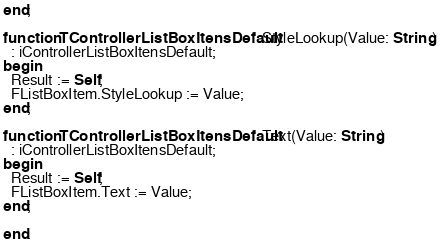<code> <loc_0><loc_0><loc_500><loc_500><_Pascal_>end;

function TControllerListBoxItensDefault.StyleLookup(Value: String)
  : iControllerListBoxItensDefault;
begin
  Result := Self;
  FListBoxItem.StyleLookup := Value;
end;

function TControllerListBoxItensDefault.Text(Value: String)
  : iControllerListBoxItensDefault;
begin
  Result := Self;
  FListBoxItem.Text := Value;
end;

end.
</code> 